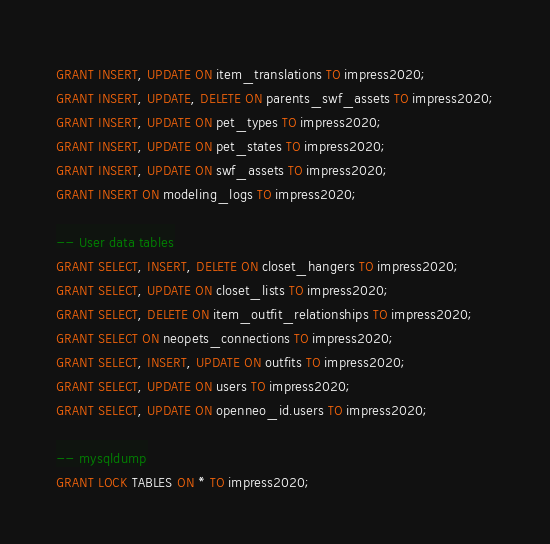<code> <loc_0><loc_0><loc_500><loc_500><_SQL_>GRANT INSERT, UPDATE ON item_translations TO impress2020;
GRANT INSERT, UPDATE, DELETE ON parents_swf_assets TO impress2020;
GRANT INSERT, UPDATE ON pet_types TO impress2020;
GRANT INSERT, UPDATE ON pet_states TO impress2020;
GRANT INSERT, UPDATE ON swf_assets TO impress2020;
GRANT INSERT ON modeling_logs TO impress2020;

-- User data tables
GRANT SELECT, INSERT, DELETE ON closet_hangers TO impress2020;
GRANT SELECT, UPDATE ON closet_lists TO impress2020;
GRANT SELECT, DELETE ON item_outfit_relationships TO impress2020;
GRANT SELECT ON neopets_connections TO impress2020;
GRANT SELECT, INSERT, UPDATE ON outfits TO impress2020;
GRANT SELECT, UPDATE ON users TO impress2020;
GRANT SELECT, UPDATE ON openneo_id.users TO impress2020;

-- mysqldump
GRANT LOCK TABLES ON * TO impress2020;
</code> 